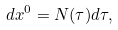<formula> <loc_0><loc_0><loc_500><loc_500>d x ^ { 0 } = N ( \tau ) d \tau ,</formula> 